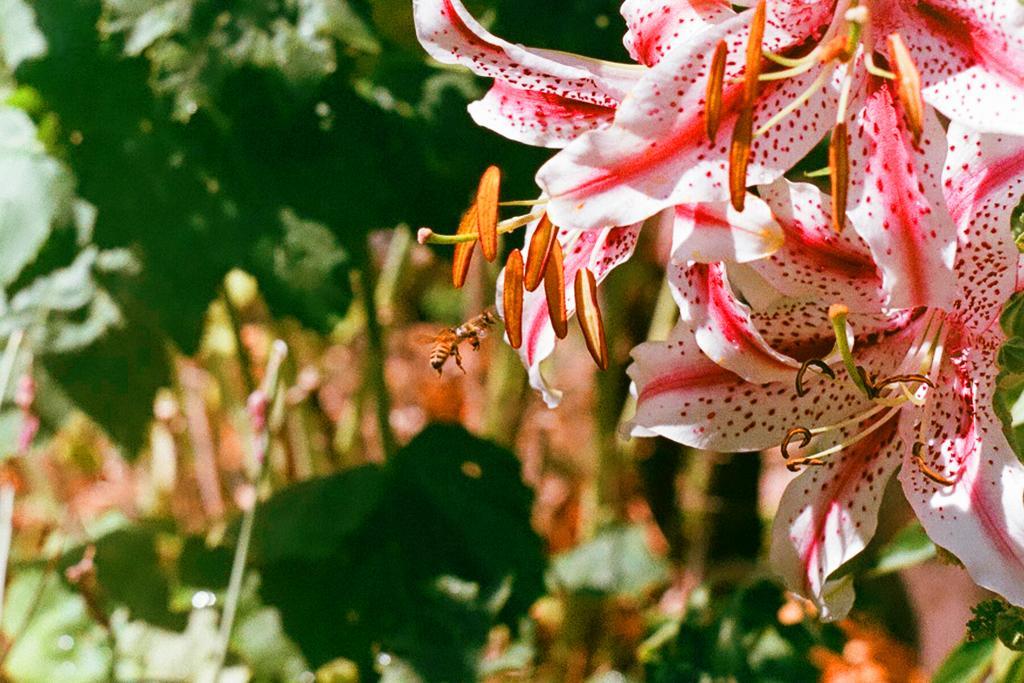Can you describe this image briefly? On the right side of the image, we can see few flowers. Background there is a blur view. Here we can see green color. 